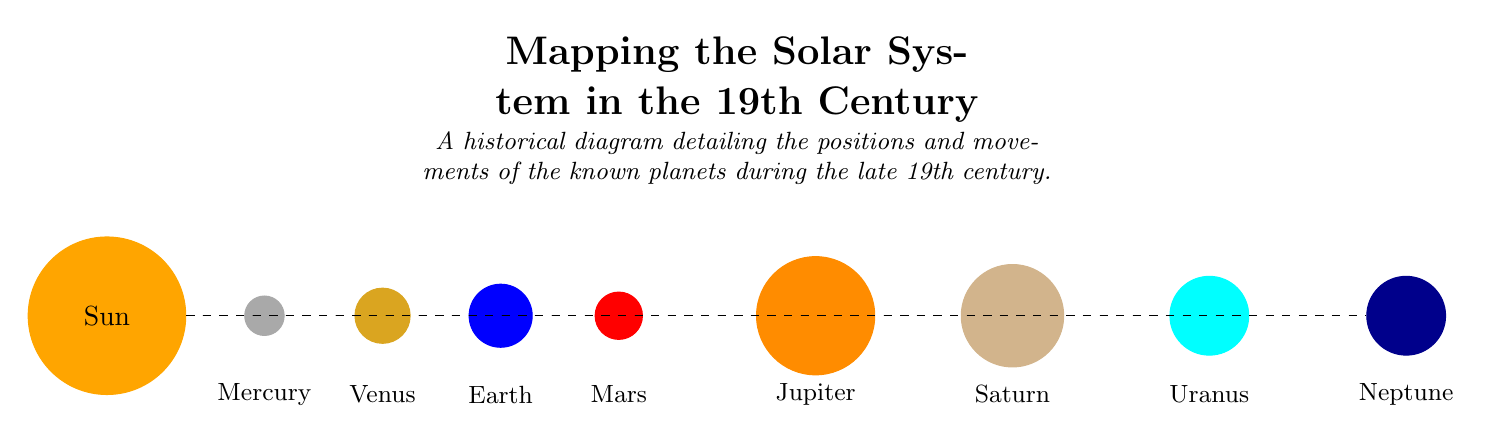What is the central body in the diagram? The diagram clearly identifies the Sun as the central body, as it is the largest circle positioned at the center (0,0).
Answer: Sun How many planets are depicted in this diagram? By counting the circles labeled with the names of planets around the Sun, we can see that there are eight distinct circles representing the known planets.
Answer: 8 Which planet is farthest from the Sun in this diagram? Observing the positions of the planets from left to right on the diagram, Neptune is placed at the farthest point from the Sun.
Answer: Neptune What color represents Mars in the diagram? The diagram shows Mars as a red circle, which is visually distinct from other planets due to its bright color.
Answer: Red Which planet is closest to the Sun? By looking at the positions of the planets, Mercury is the first planet on the left, indicating it is closest to the Sun.
Answer: Mercury Which two planets are depicted directly after Earth in the diagram? The planets are arranged sequentially, and after Earth (5,0), the next two planets are Mars (6.5,0) and Jupiter (9,0).
Answer: Mars and Jupiter How are the planets connected in the diagram? The diagram illustrates dashed lines from the Sun to each planet, showing a connection that represents the gravitational attraction or orbital paths each planet maintains around the Sun.
Answer: Dashed lines What is the title of the diagram? The title is prominently displayed at the top of the diagram and reads, "Mapping the Solar System in the 19th Century."
Answer: Mapping the Solar System in the 19th Century What is the color representing Venus in this diagram? Venus is depicted in a color that is a shade of yellow, specifically a golden yellow circle located third from the left.
Answer: Golden yellow 